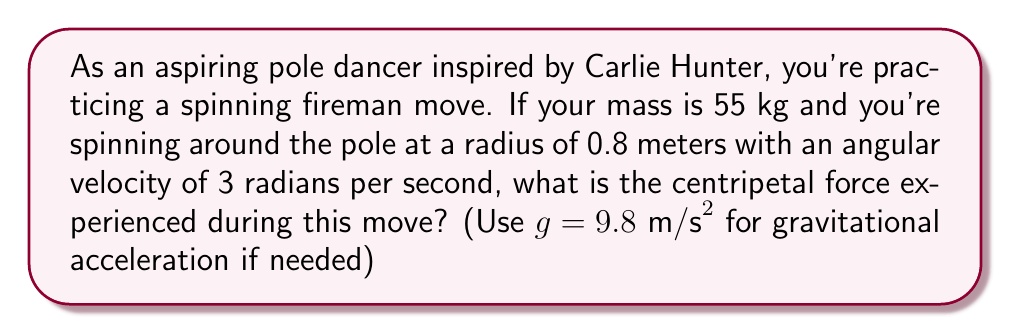Help me with this question. To solve this problem, we'll use the formula for centripetal force:

$$ F_c = m\omega^2r $$

Where:
$F_c$ = centripetal force (N)
$m$ = mass (kg)
$\omega$ = angular velocity (rad/s)
$r$ = radius of rotation (m)

Given:
$m = 55$ kg
$r = 0.8$ m
$\omega = 3$ rad/s

Let's substitute these values into the formula:

$$ F_c = 55 \cdot 3^2 \cdot 0.8 $$

First, calculate $3^2$:
$$ F_c = 55 \cdot 9 \cdot 0.8 $$

Now multiply:
$$ F_c = 396 \text{ N} $$

Therefore, the centripetal force experienced during this pole dancing move is 396 N.
Answer: $396 \text{ N}$ 